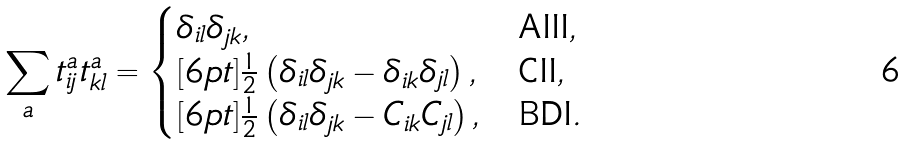<formula> <loc_0><loc_0><loc_500><loc_500>\sum _ { a } t ^ { a } _ { i j } t ^ { a } _ { k l } = \begin{cases} \delta _ { i l } \delta _ { j k } , & \text {AIII} , \\ [ 6 p t ] \frac { 1 } { 2 } \left ( \delta _ { i l } \delta _ { j k } - \delta _ { i k } \delta _ { j l } \right ) , & \text {CII} , \\ [ 6 p t ] \frac { 1 } { 2 } \left ( \delta _ { i l } \delta _ { j k } - C _ { i k } C _ { j l } \right ) , & \text {BDI} . \end{cases}</formula> 